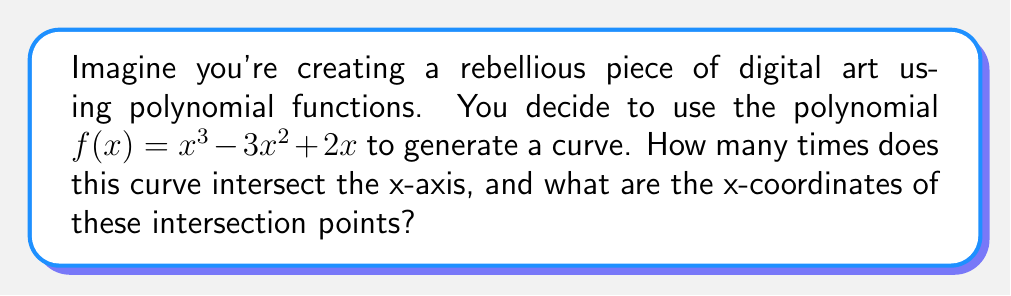Can you answer this question? Let's approach this step-by-step:

1) To find where the curve intersects the x-axis, we need to solve the equation:

   $f(x) = 0$

2) Substituting our polynomial:

   $x^3 - 3x^2 + 2x = 0$

3) Factor out x:

   $x(x^2 - 3x + 2) = 0$

4) Use the zero product property. Either $x = 0$ or $x^2 - 3x + 2 = 0$

5) For the quadratic part, use the quadratic formula:

   $x = \frac{-b \pm \sqrt{b^2 - 4ac}}{2a}$

   Where $a = 1$, $b = -3$, and $c = 2$

6) Substituting:

   $x = \frac{3 \pm \sqrt{9 - 8}}{2} = \frac{3 \pm 1}{2}$

7) This gives us:

   $x = 2$ or $x = 1$

8) Combining with our earlier result of $x = 0$, we have three solutions:

   $x = 0$, $x = 1$, and $x = 2$

Therefore, the curve intersects the x-axis at three points: (0,0), (1,0), and (2,0).

[asy]
import graph;
size(200,200);
real f(real x) {return x^3 - 3x^2 + 2x;}
draw(graph(f,-0.5,2.5));
draw((-0.5,0)--(2.5,0),arrow=Arrow(TeXHead));
draw((0,-1)--(0,3),arrow=Arrow(TeXHead));
dot((0,0));
dot((1,0));
dot((2,0));
label("y", (0,3), N);
label("x", (2.5,0), E);
[/asy]

This creates an S-shaped curve that crosses the x-axis three times, demonstrating how a simple polynomial can create an intriguing visual pattern.
Answer: 3 intersections: (0,0), (1,0), (2,0) 